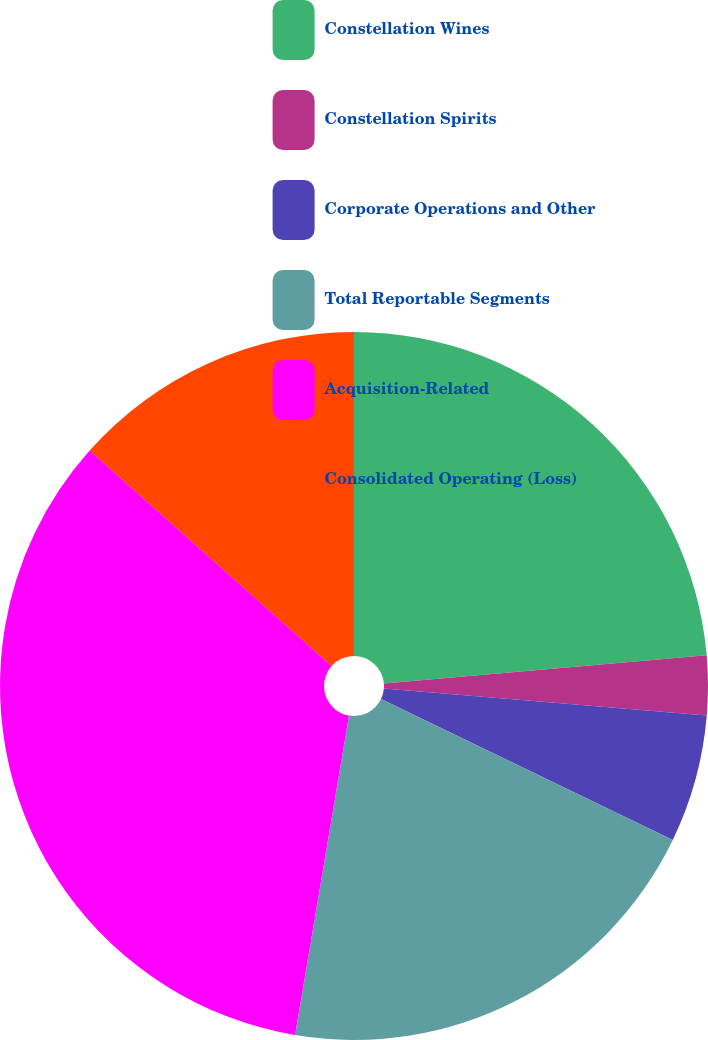Convert chart. <chart><loc_0><loc_0><loc_500><loc_500><pie_chart><fcel>Constellation Wines<fcel>Constellation Spirits<fcel>Corporate Operations and Other<fcel>Total Reportable Segments<fcel>Acquisition-Related<fcel>Consolidated Operating (Loss)<nl><fcel>23.62%<fcel>2.71%<fcel>5.83%<fcel>20.5%<fcel>33.92%<fcel>13.42%<nl></chart> 